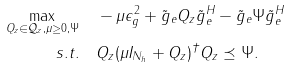Convert formula to latex. <formula><loc_0><loc_0><loc_500><loc_500>\max _ { Q _ { z } \in \mathcal { Q } _ { z } , \mu \geq 0 , \Psi } & \quad - \mu \epsilon _ { g } ^ { 2 } + \tilde { g } _ { e } Q _ { z } \tilde { g } _ { e } ^ { H } - \tilde { g } _ { e } \Psi \tilde { g } _ { e } ^ { H } \\ { s . t . } & \quad Q _ { z } ( \mu I _ { N _ { h } } + Q _ { z } ) ^ { \dag } Q _ { z } \preceq \Psi .</formula> 